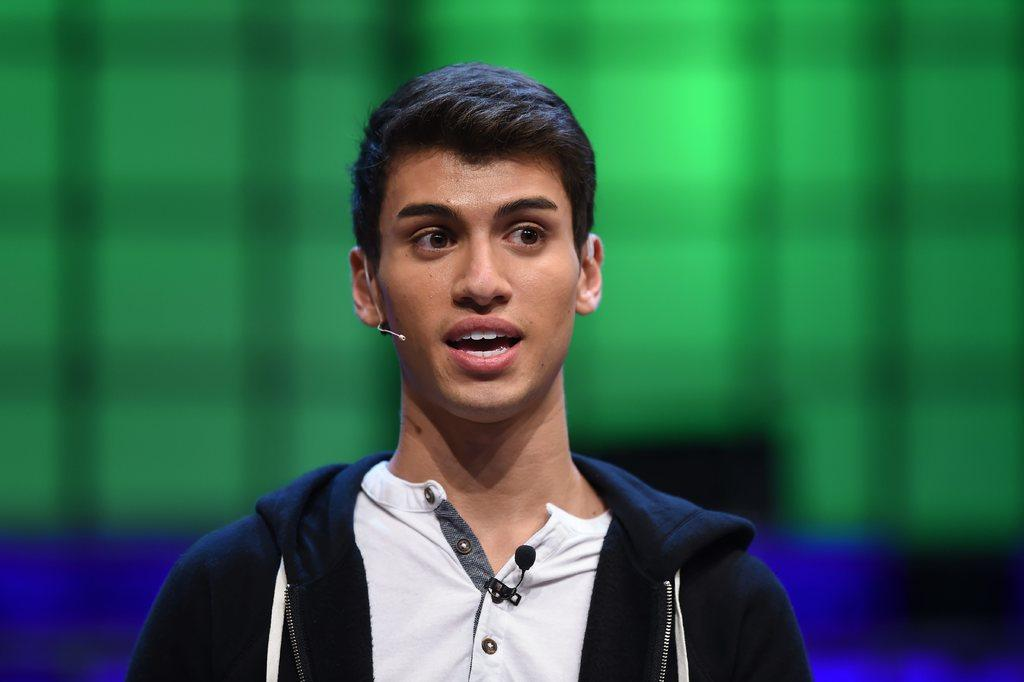Who is present in the image? There is a man in the image. What is the man doing in the image? The man is speaking. What is the man wearing in the image? The man is wearing a jacket. Can you describe the man's attire in more detail? There is a microphone on the man's t-shirt. What can be observed about the background of the image? The background of the image is blurry. How many cats are visible in the image? There are no cats present in the image. What type of voyage is the man embarking on in the image? There is no indication of a voyage in the image; the man is simply speaking. 